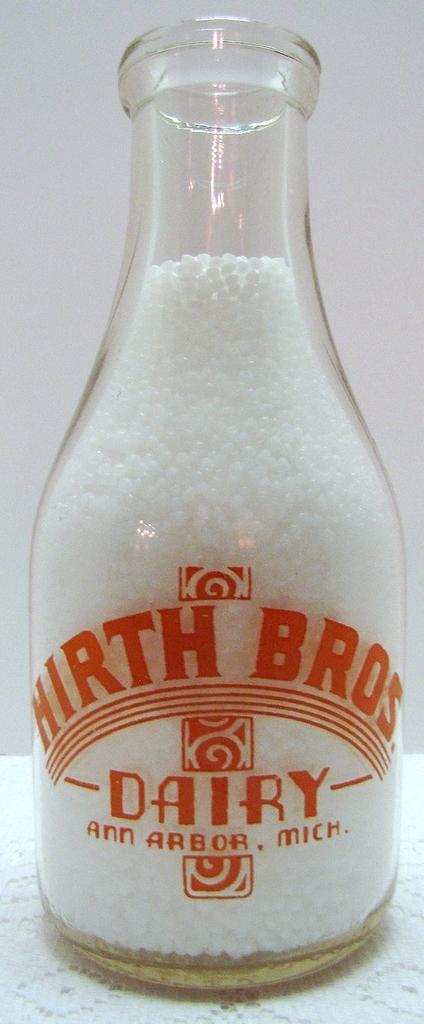Can you describe this image briefly? There is a bottle which has bros dairy written on it and it contains something inside it. 